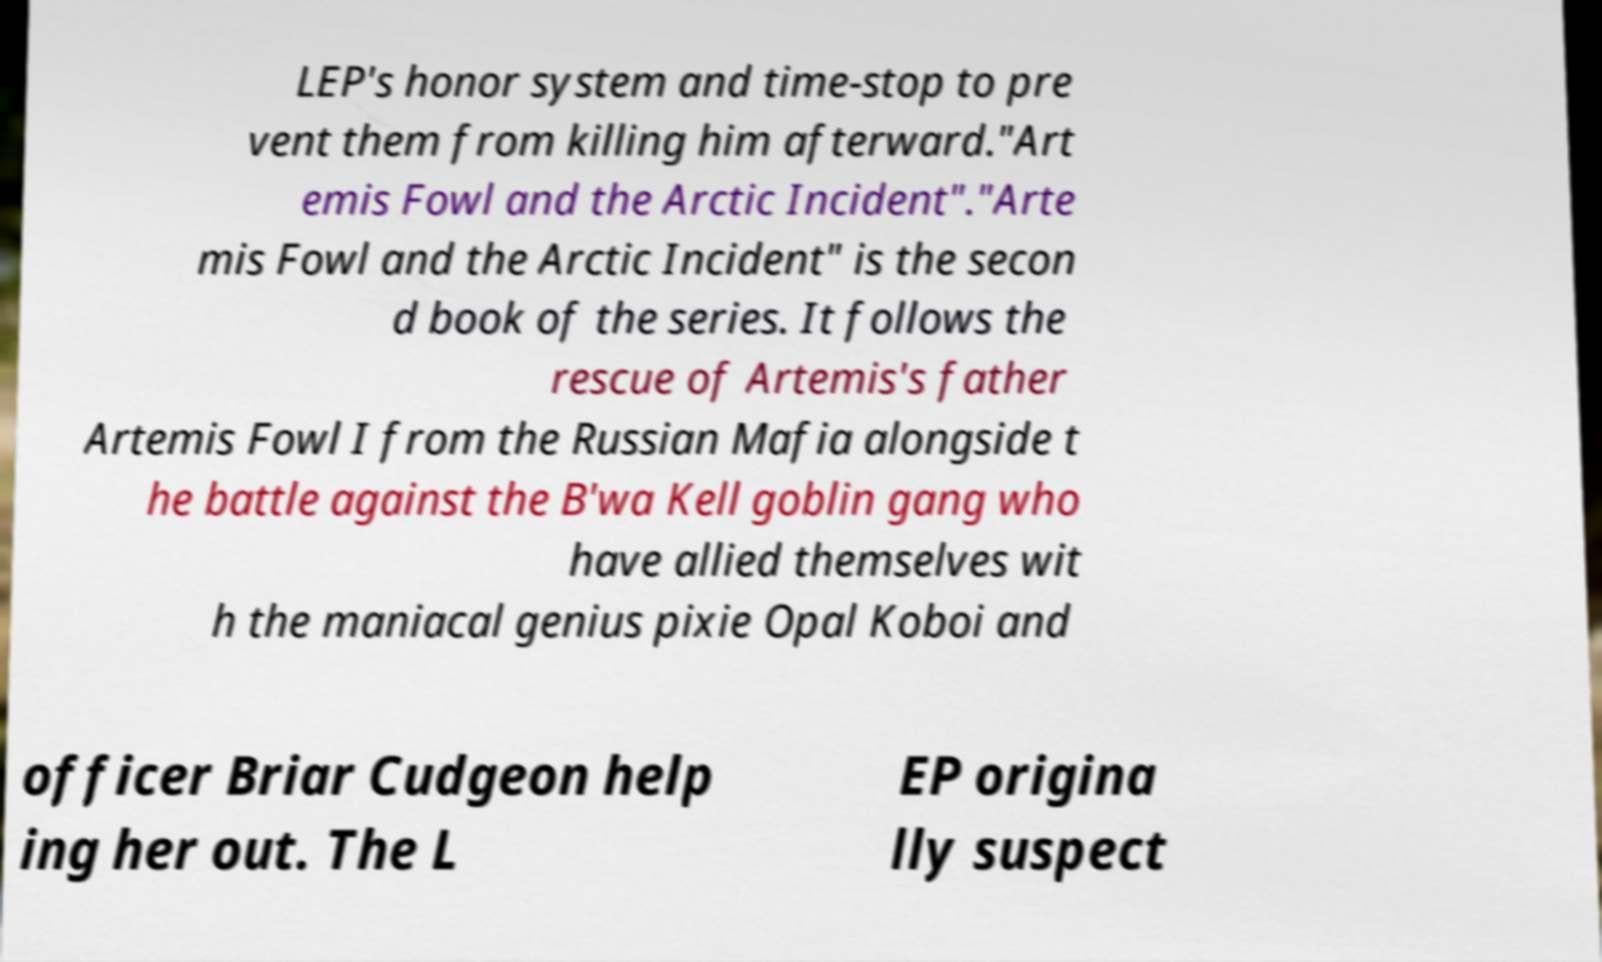For documentation purposes, I need the text within this image transcribed. Could you provide that? LEP's honor system and time-stop to pre vent them from killing him afterward."Art emis Fowl and the Arctic Incident"."Arte mis Fowl and the Arctic Incident" is the secon d book of the series. It follows the rescue of Artemis's father Artemis Fowl I from the Russian Mafia alongside t he battle against the B'wa Kell goblin gang who have allied themselves wit h the maniacal genius pixie Opal Koboi and officer Briar Cudgeon help ing her out. The L EP origina lly suspect 